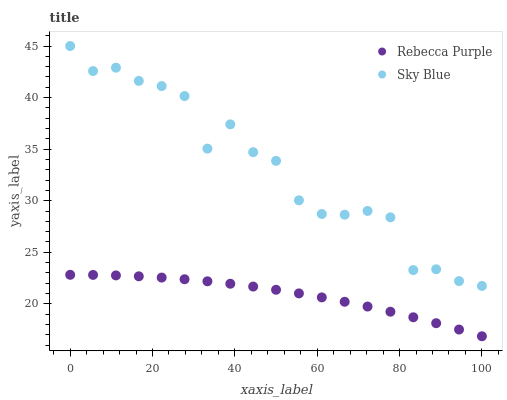Does Rebecca Purple have the minimum area under the curve?
Answer yes or no. Yes. Does Sky Blue have the maximum area under the curve?
Answer yes or no. Yes. Does Rebecca Purple have the maximum area under the curve?
Answer yes or no. No. Is Rebecca Purple the smoothest?
Answer yes or no. Yes. Is Sky Blue the roughest?
Answer yes or no. Yes. Is Rebecca Purple the roughest?
Answer yes or no. No. Does Rebecca Purple have the lowest value?
Answer yes or no. Yes. Does Sky Blue have the highest value?
Answer yes or no. Yes. Does Rebecca Purple have the highest value?
Answer yes or no. No. Is Rebecca Purple less than Sky Blue?
Answer yes or no. Yes. Is Sky Blue greater than Rebecca Purple?
Answer yes or no. Yes. Does Rebecca Purple intersect Sky Blue?
Answer yes or no. No. 